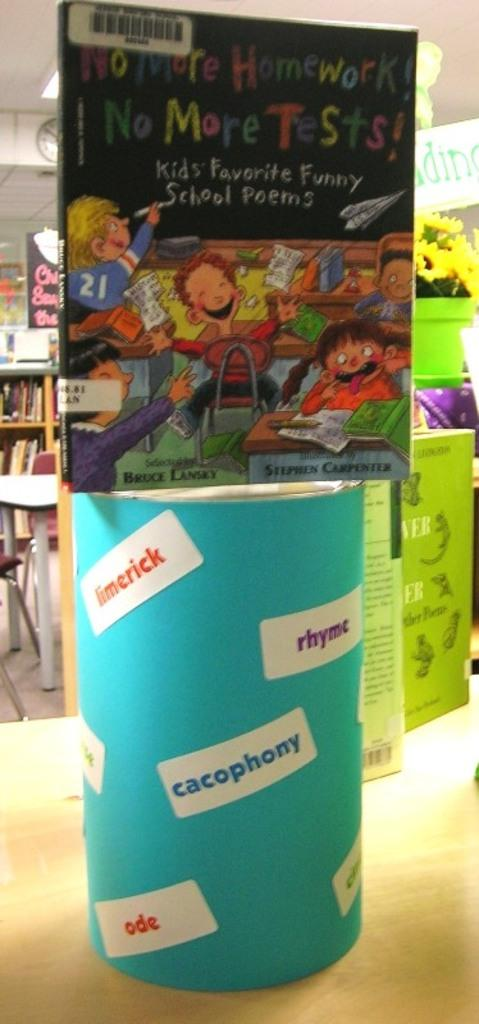<image>
Summarize the visual content of the image. A children's book rests on top of a stand that has the word cacophony displayed. 